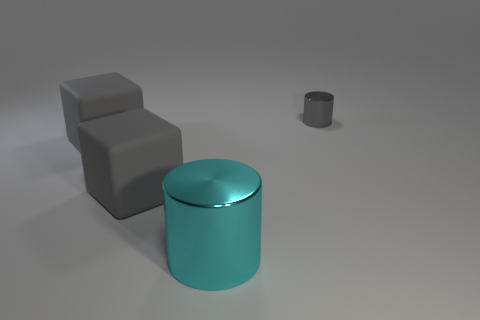Add 3 tiny red matte balls. How many objects exist? 7 Add 1 large cyan shiny things. How many large cyan shiny things are left? 2 Add 1 small brown metallic balls. How many small brown metallic balls exist? 1 Subtract 0 purple cylinders. How many objects are left? 4 Subtract all matte things. Subtract all big shiny objects. How many objects are left? 1 